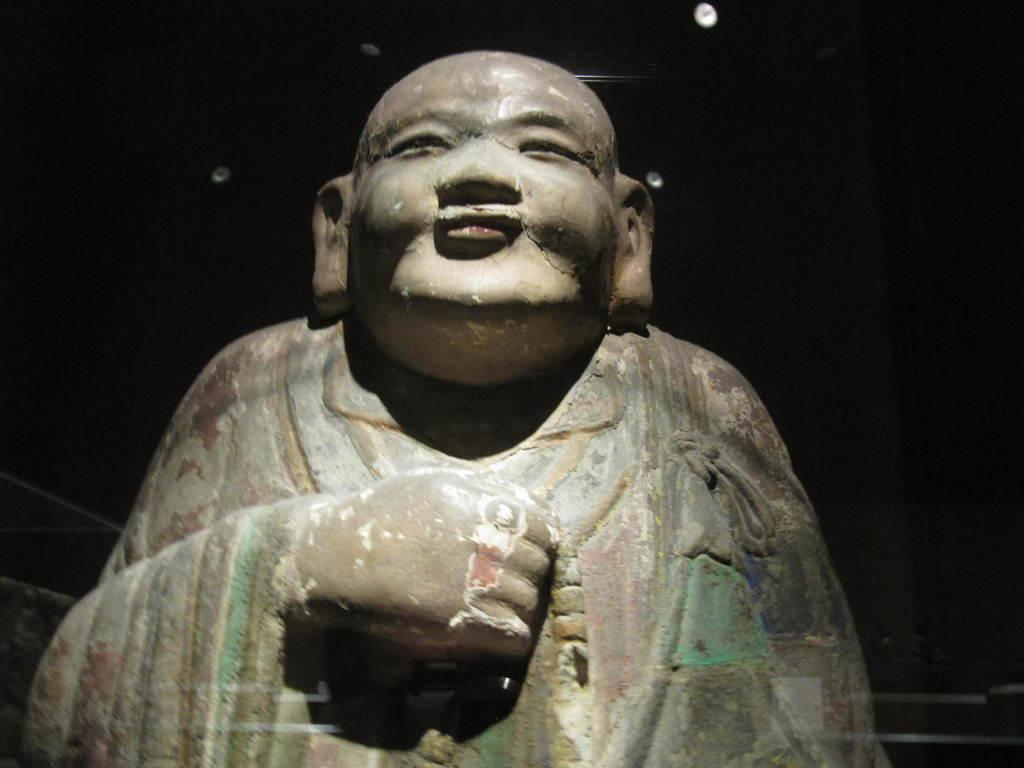What is the main subject of the image? There is a statue in the image. What type of machine is producing smoke in the image? There is no machine or smoke present in the image; it only features a statue. What songs can be heard playing in the background of the image? There is no audio or music present in the image; it only features a statue. 